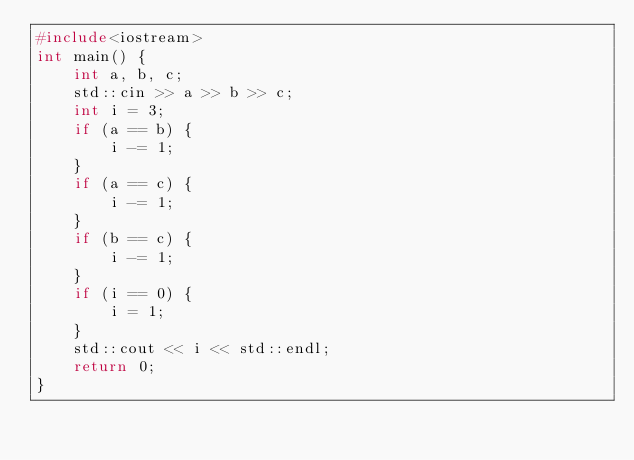<code> <loc_0><loc_0><loc_500><loc_500><_C++_>#include<iostream>
int main() {
	int a, b, c;
	std::cin >> a >> b >> c;
	int i = 3;
	if (a == b) {
		i -= 1;
	}
	if (a == c) {
		i -= 1;
	}
	if (b == c) {
		i -= 1;
	}
	if (i == 0) {
		i = 1;
	}
	std::cout << i << std::endl;
	return 0;
}</code> 